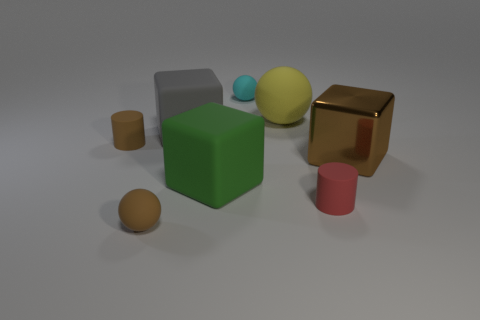What number of other things are the same shape as the big brown metal object?
Ensure brevity in your answer.  2. There is a tiny object that is in front of the small brown cylinder and to the right of the gray block; what is its color?
Your response must be concise. Red. The metal block has what color?
Ensure brevity in your answer.  Brown. Is the material of the gray thing the same as the tiny brown object that is behind the large green rubber object?
Ensure brevity in your answer.  Yes. There is a tiny cyan object that is the same material as the small brown cylinder; what shape is it?
Offer a terse response. Sphere. What is the color of the other matte cylinder that is the same size as the brown cylinder?
Provide a short and direct response. Red. There is a thing right of the red matte thing; is it the same size as the red thing?
Provide a succinct answer. No. Is the metallic cube the same color as the big sphere?
Your answer should be very brief. No. What number of tiny brown metal things are there?
Give a very brief answer. 0. What number of cylinders are big gray objects or cyan objects?
Keep it short and to the point. 0. 